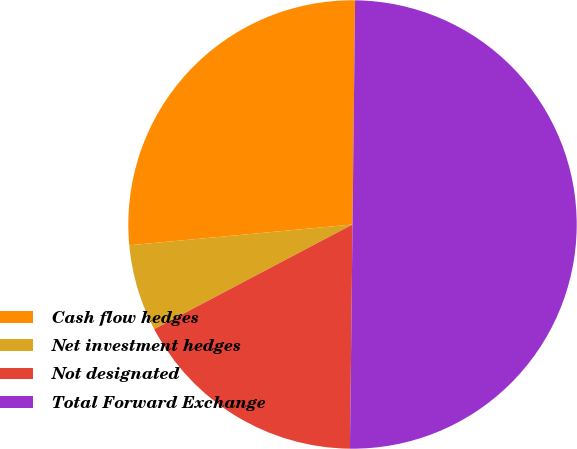<chart> <loc_0><loc_0><loc_500><loc_500><pie_chart><fcel>Cash flow hedges<fcel>Net investment hedges<fcel>Not designated<fcel>Total Forward Exchange<nl><fcel>26.66%<fcel>6.25%<fcel>17.09%<fcel>50.0%<nl></chart> 